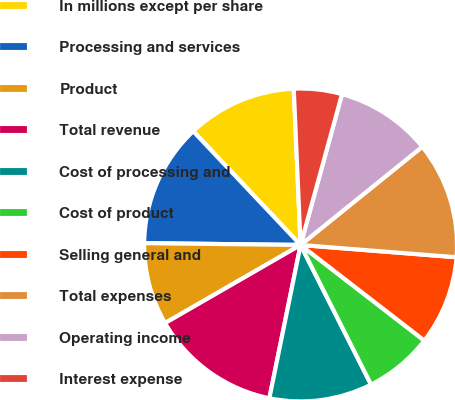Convert chart to OTSL. <chart><loc_0><loc_0><loc_500><loc_500><pie_chart><fcel>In millions except per share<fcel>Processing and services<fcel>Product<fcel>Total revenue<fcel>Cost of processing and<fcel>Cost of product<fcel>Selling general and<fcel>Total expenses<fcel>Operating income<fcel>Interest expense<nl><fcel>11.35%<fcel>12.77%<fcel>8.51%<fcel>13.48%<fcel>10.64%<fcel>7.09%<fcel>9.22%<fcel>12.06%<fcel>9.93%<fcel>4.96%<nl></chart> 